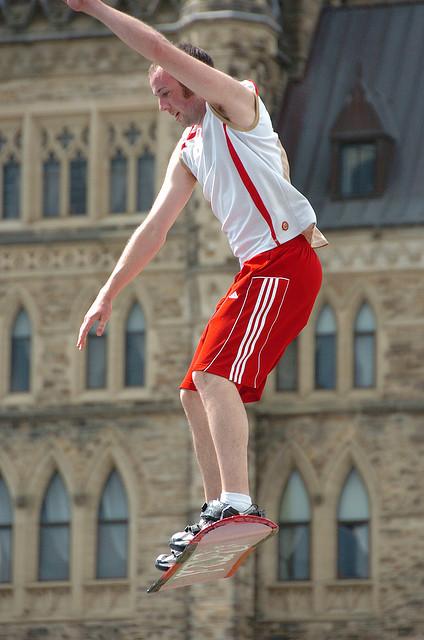Are the man's clothes color coordinated?
Concise answer only. Yes. Does this look like it would be fun?
Be succinct. Yes. Where is the man looking?
Quick response, please. Down. What is the man standing on?
Concise answer only. Snowboard. 